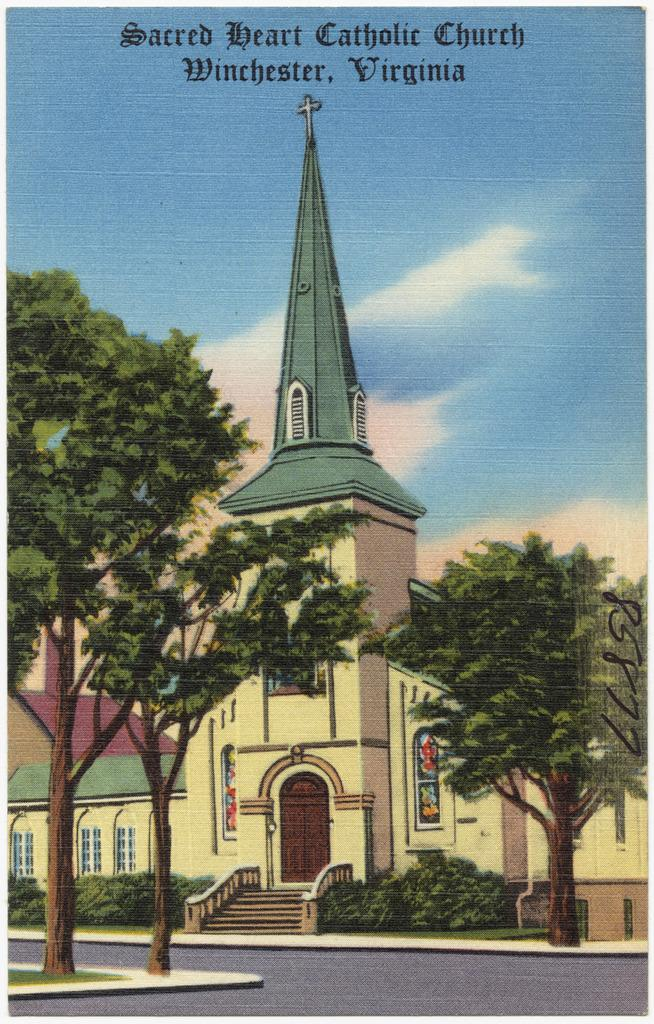What type of image is being described? The image is a painted one. What can be seen on either side of the image? There are trees on either side of the image. What is the main structure in the middle of the image? There is a church in the middle of the image. What is visible at the top of the image? The sky is visible at the top of the image. What color is present in the image? There is a matter in black color in the image. What year was the camera used to capture this image? The image is a painting, not a photograph, so there is no camera involved in its creation. 